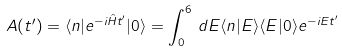<formula> <loc_0><loc_0><loc_500><loc_500>A ( t ^ { \prime } ) = \langle n | e ^ { - i \hat { H } t ^ { \prime } } | 0 \rangle = \int ^ { 6 } _ { 0 } \, d E \langle n | E \rangle \langle E | 0 \rangle e ^ { - i E t ^ { \prime } }</formula> 